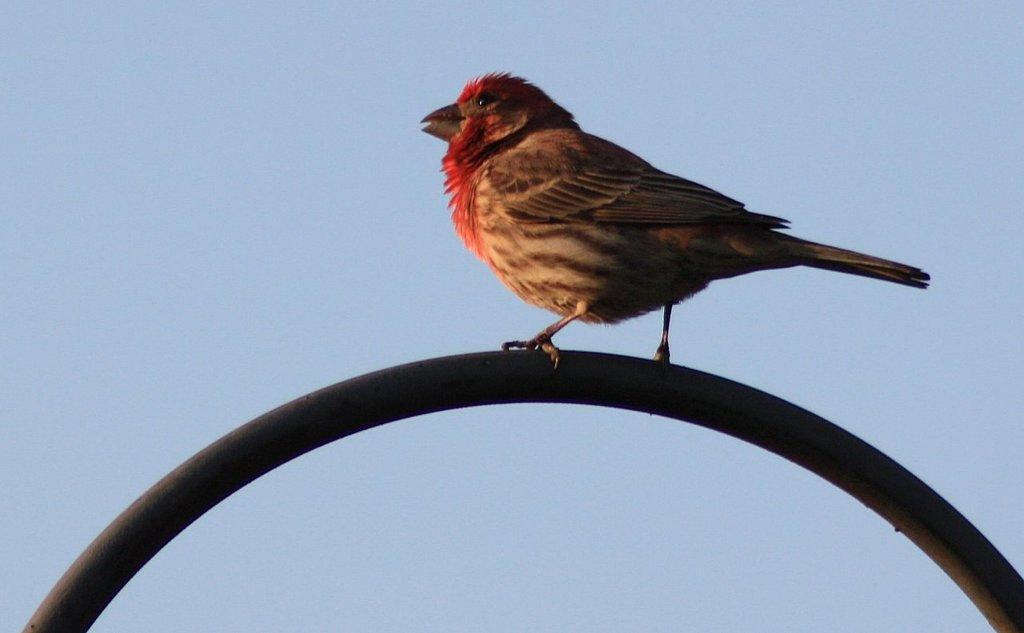Where was the image taken? The image is taken outdoors. What can be seen in the image besides the outdoor setting? There is a bird in the image. What is the bird perched on? The bird is on a metal rod. What can be seen in the background of the image? The sky is visible in the background of the image. What type of frog can be seen in the aftermath of the explosion in the image? There is no frog or explosion present in the image. What kind of apparatus is the bird using to communicate in the image? The bird is not using any apparatus to communicate in the image; it is simply perched on a metal rod. 